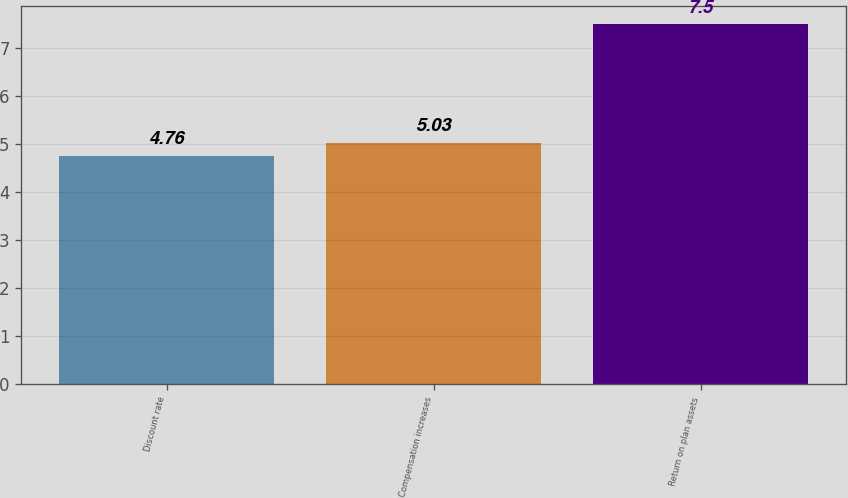Convert chart. <chart><loc_0><loc_0><loc_500><loc_500><bar_chart><fcel>Discount rate<fcel>Compensation increases<fcel>Return on plan assets<nl><fcel>4.76<fcel>5.03<fcel>7.5<nl></chart> 